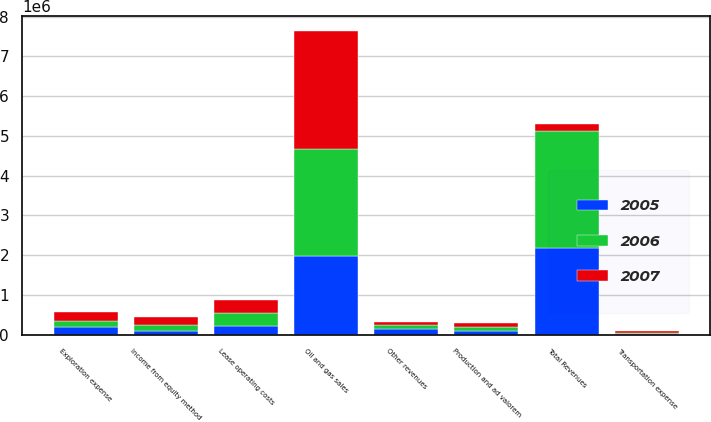Convert chart to OTSL. <chart><loc_0><loc_0><loc_500><loc_500><stacked_bar_chart><ecel><fcel>Oil and gas sales<fcel>Income from equity method<fcel>Other revenues<fcel>Total Revenues<fcel>Lease operating costs<fcel>Production and ad valorem<fcel>Transportation expense<fcel>Exploration expense<nl><fcel>2007<fcel>2.9661e+06<fcel>210928<fcel>95003<fcel>167924<fcel>322452<fcel>113547<fcel>51699<fcel>219082<nl><fcel>2006<fcel>2.70124e+06<fcel>139362<fcel>99479<fcel>2.94008e+06<fcel>317087<fcel>108979<fcel>28542<fcel>167924<nl><fcel>2005<fcel>1.96642e+06<fcel>90812<fcel>129489<fcel>2.18672e+06<fcel>217860<fcel>78703<fcel>16764<fcel>178426<nl></chart> 